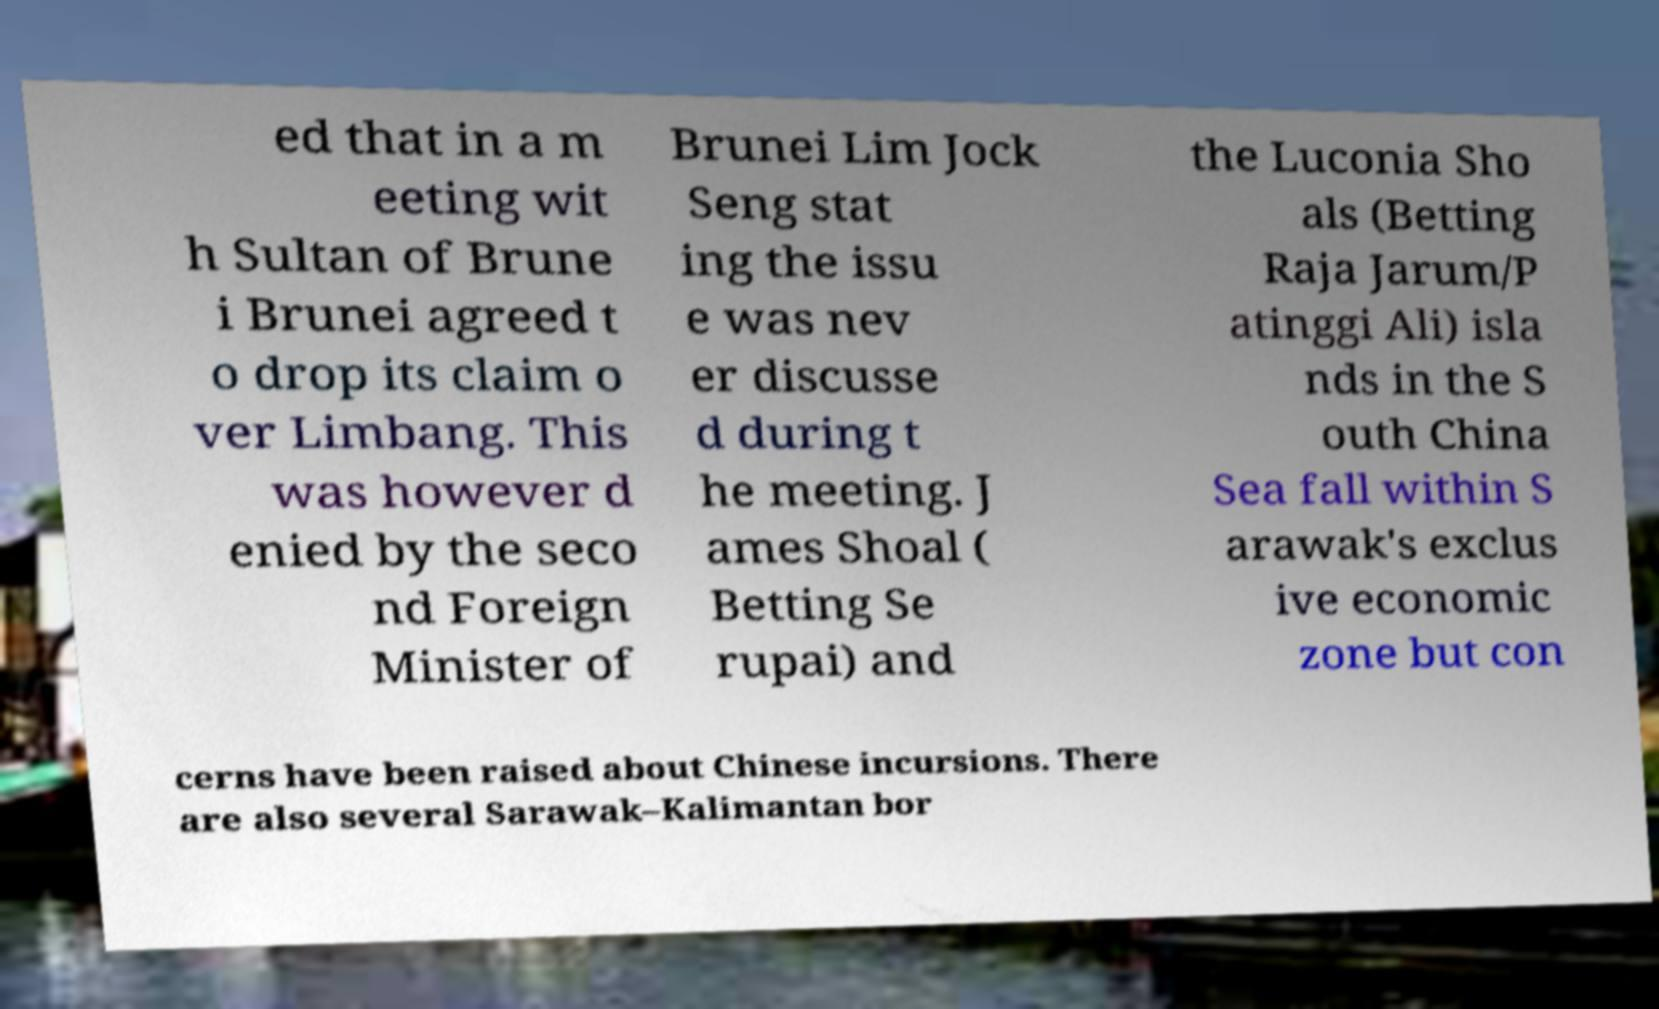I need the written content from this picture converted into text. Can you do that? ed that in a m eeting wit h Sultan of Brune i Brunei agreed t o drop its claim o ver Limbang. This was however d enied by the seco nd Foreign Minister of Brunei Lim Jock Seng stat ing the issu e was nev er discusse d during t he meeting. J ames Shoal ( Betting Se rupai) and the Luconia Sho als (Betting Raja Jarum/P atinggi Ali) isla nds in the S outh China Sea fall within S arawak's exclus ive economic zone but con cerns have been raised about Chinese incursions. There are also several Sarawak–Kalimantan bor 